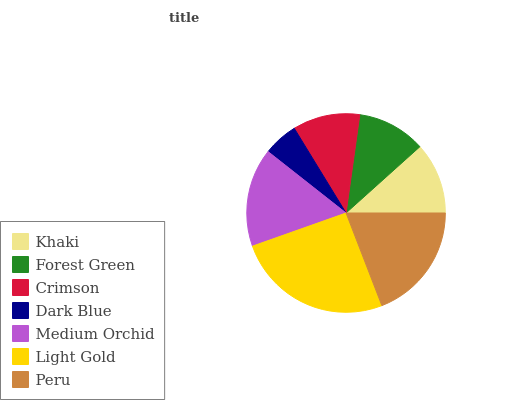Is Dark Blue the minimum?
Answer yes or no. Yes. Is Light Gold the maximum?
Answer yes or no. Yes. Is Forest Green the minimum?
Answer yes or no. No. Is Forest Green the maximum?
Answer yes or no. No. Is Khaki greater than Forest Green?
Answer yes or no. Yes. Is Forest Green less than Khaki?
Answer yes or no. Yes. Is Forest Green greater than Khaki?
Answer yes or no. No. Is Khaki less than Forest Green?
Answer yes or no. No. Is Khaki the high median?
Answer yes or no. Yes. Is Khaki the low median?
Answer yes or no. Yes. Is Forest Green the high median?
Answer yes or no. No. Is Forest Green the low median?
Answer yes or no. No. 